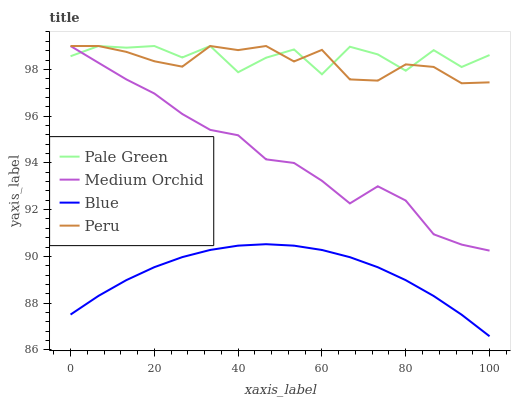Does Blue have the minimum area under the curve?
Answer yes or no. Yes. Does Pale Green have the maximum area under the curve?
Answer yes or no. Yes. Does Medium Orchid have the minimum area under the curve?
Answer yes or no. No. Does Medium Orchid have the maximum area under the curve?
Answer yes or no. No. Is Blue the smoothest?
Answer yes or no. Yes. Is Pale Green the roughest?
Answer yes or no. Yes. Is Medium Orchid the smoothest?
Answer yes or no. No. Is Medium Orchid the roughest?
Answer yes or no. No. Does Blue have the lowest value?
Answer yes or no. Yes. Does Medium Orchid have the lowest value?
Answer yes or no. No. Does Peru have the highest value?
Answer yes or no. Yes. Is Blue less than Peru?
Answer yes or no. Yes. Is Peru greater than Blue?
Answer yes or no. Yes. Does Peru intersect Medium Orchid?
Answer yes or no. Yes. Is Peru less than Medium Orchid?
Answer yes or no. No. Is Peru greater than Medium Orchid?
Answer yes or no. No. Does Blue intersect Peru?
Answer yes or no. No. 